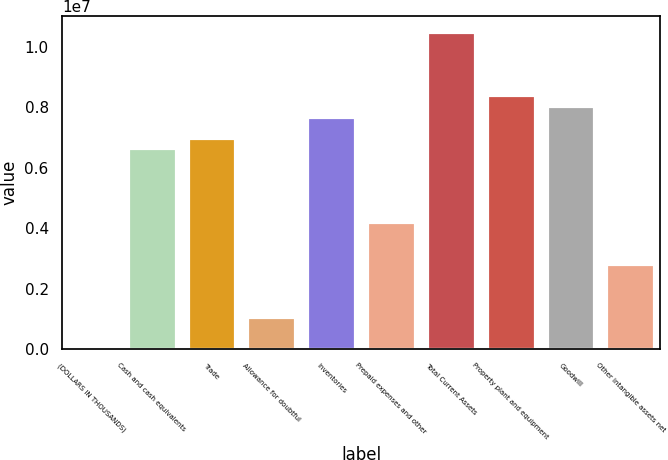Convert chart to OTSL. <chart><loc_0><loc_0><loc_500><loc_500><bar_chart><fcel>(DOLLARS IN THOUSANDS)<fcel>Cash and cash equivalents<fcel>Trade<fcel>Allowance for doubtful<fcel>Inventories<fcel>Prepaid expenses and other<fcel>Total Current Assets<fcel>Property plant and equipment<fcel>Goodwill<fcel>Other intangible assets net<nl><fcel>2014<fcel>6.63797e+06<fcel>6.98723e+06<fcel>1.0498e+06<fcel>7.68575e+06<fcel>4.19314e+06<fcel>1.04798e+07<fcel>8.38427e+06<fcel>8.03501e+06<fcel>2.7961e+06<nl></chart> 